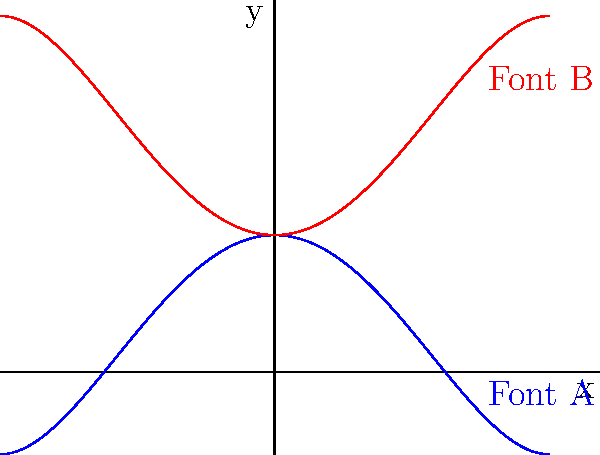As you prepare for a museum blessing ceremony, you notice two holy water fonts with shapes resembling polynomial functions. The blue curve represents Font A, and the red curve represents Font B. Which of these fonts is better described by the quartic function $f(x) = 0.1x^4 - 0.8x^2 + 1$, and how does this shape relate to its spiritual significance? To determine which font is better described by the given function, let's analyze the properties of $f(x) = 0.1x^4 - 0.8x^2 + 1$:

1. The leading coefficient is positive (0.1), so the function opens upward at the extremes.
2. The negative coefficient of $x^2$ (-0.8) creates a local maximum at x = 0.
3. The constant term (1) shifts the entire function up by 1 unit.

Comparing these properties to the graphs:

1. Font A (blue) opens upward at the extremes, matching the positive leading coefficient.
2. Font A has a local maximum at x = 0, consistent with the negative $x^2$ term.
3. Font A's y-intercept is at (0,1), matching the constant term.

Font B (red) has opposite characteristics: it opens downward and has a local minimum at x = 0.

Spiritually, Font A's shape can be interpreted as follows:
1. The upward opening represents reaching towards heaven.
2. The central peak symbolizes the divine presence at the center of our faith.
3. The symmetry reflects balance and harmony in spiritual life.

Therefore, Font A is better described by the given quartic function and carries these spiritual connotations.
Answer: Font A; upward reach, central divine presence, spiritual balance 